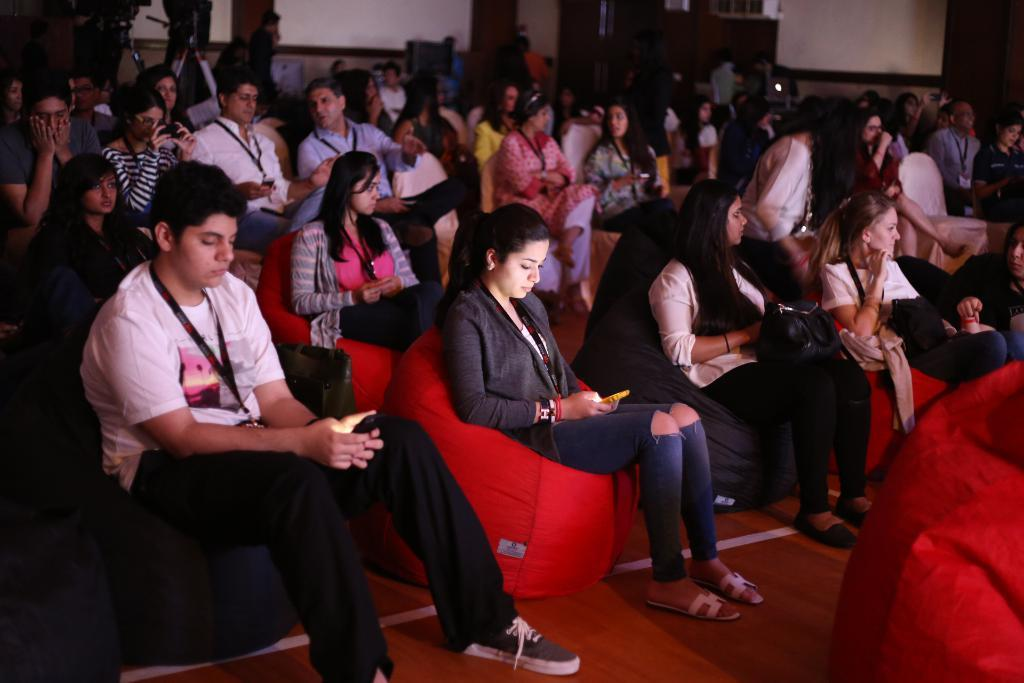What type of view is shown in the image? The image is an inside view. What are the people in the image doing? The people are sitting on chairs and facing towards the right side. What can be seen in the background of the image? There are camera stands and a wall in the background. What type of creature can be seen holding a fork in the image? There is no creature holding a fork present in the image. What town is visible in the background of the image? The image does not show a town; it is an inside view with a wall and camera stands in the background. 